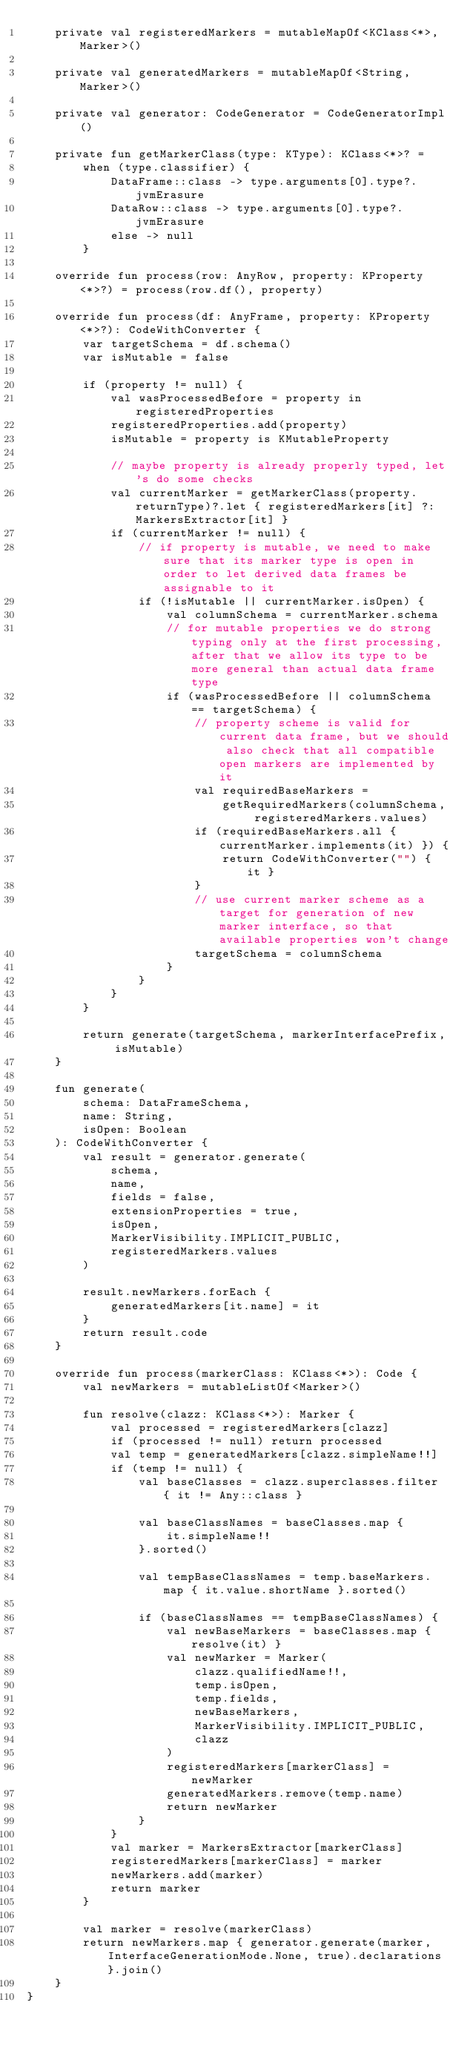<code> <loc_0><loc_0><loc_500><loc_500><_Kotlin_>    private val registeredMarkers = mutableMapOf<KClass<*>, Marker>()

    private val generatedMarkers = mutableMapOf<String, Marker>()

    private val generator: CodeGenerator = CodeGeneratorImpl()

    private fun getMarkerClass(type: KType): KClass<*>? =
        when (type.classifier) {
            DataFrame::class -> type.arguments[0].type?.jvmErasure
            DataRow::class -> type.arguments[0].type?.jvmErasure
            else -> null
        }

    override fun process(row: AnyRow, property: KProperty<*>?) = process(row.df(), property)

    override fun process(df: AnyFrame, property: KProperty<*>?): CodeWithConverter {
        var targetSchema = df.schema()
        var isMutable = false

        if (property != null) {
            val wasProcessedBefore = property in registeredProperties
            registeredProperties.add(property)
            isMutable = property is KMutableProperty

            // maybe property is already properly typed, let's do some checks
            val currentMarker = getMarkerClass(property.returnType)?.let { registeredMarkers[it] ?: MarkersExtractor[it] }
            if (currentMarker != null) {
                // if property is mutable, we need to make sure that its marker type is open in order to let derived data frames be assignable to it
                if (!isMutable || currentMarker.isOpen) {
                    val columnSchema = currentMarker.schema
                    // for mutable properties we do strong typing only at the first processing, after that we allow its type to be more general than actual data frame type
                    if (wasProcessedBefore || columnSchema == targetSchema) {
                        // property scheme is valid for current data frame, but we should also check that all compatible open markers are implemented by it
                        val requiredBaseMarkers =
                            getRequiredMarkers(columnSchema, registeredMarkers.values)
                        if (requiredBaseMarkers.all { currentMarker.implements(it) }) {
                            return CodeWithConverter("") { it }
                        }
                        // use current marker scheme as a target for generation of new marker interface, so that available properties won't change
                        targetSchema = columnSchema
                    }
                }
            }
        }

        return generate(targetSchema, markerInterfacePrefix, isMutable)
    }

    fun generate(
        schema: DataFrameSchema,
        name: String,
        isOpen: Boolean
    ): CodeWithConverter {
        val result = generator.generate(
            schema,
            name,
            fields = false,
            extensionProperties = true,
            isOpen,
            MarkerVisibility.IMPLICIT_PUBLIC,
            registeredMarkers.values
        )

        result.newMarkers.forEach {
            generatedMarkers[it.name] = it
        }
        return result.code
    }

    override fun process(markerClass: KClass<*>): Code {
        val newMarkers = mutableListOf<Marker>()

        fun resolve(clazz: KClass<*>): Marker {
            val processed = registeredMarkers[clazz]
            if (processed != null) return processed
            val temp = generatedMarkers[clazz.simpleName!!]
            if (temp != null) {
                val baseClasses = clazz.superclasses.filter { it != Any::class }

                val baseClassNames = baseClasses.map {
                    it.simpleName!!
                }.sorted()

                val tempBaseClassNames = temp.baseMarkers.map { it.value.shortName }.sorted()

                if (baseClassNames == tempBaseClassNames) {
                    val newBaseMarkers = baseClasses.map { resolve(it) }
                    val newMarker = Marker(
                        clazz.qualifiedName!!,
                        temp.isOpen,
                        temp.fields,
                        newBaseMarkers,
                        MarkerVisibility.IMPLICIT_PUBLIC,
                        clazz
                    )
                    registeredMarkers[markerClass] = newMarker
                    generatedMarkers.remove(temp.name)
                    return newMarker
                }
            }
            val marker = MarkersExtractor[markerClass]
            registeredMarkers[markerClass] = marker
            newMarkers.add(marker)
            return marker
        }

        val marker = resolve(markerClass)
        return newMarkers.map { generator.generate(marker, InterfaceGenerationMode.None, true).declarations }.join()
    }
}
</code> 